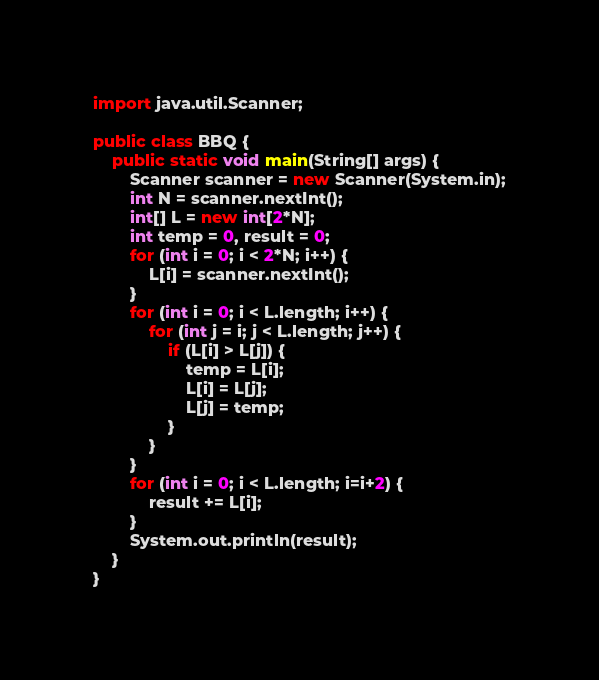<code> <loc_0><loc_0><loc_500><loc_500><_Java_>import java.util.Scanner;

public class BBQ {
    public static void main(String[] args) {
        Scanner scanner = new Scanner(System.in);
        int N = scanner.nextInt();
        int[] L = new int[2*N];
        int temp = 0, result = 0;
        for (int i = 0; i < 2*N; i++) {
            L[i] = scanner.nextInt();
        }
        for (int i = 0; i < L.length; i++) {
            for (int j = i; j < L.length; j++) {
                if (L[i] > L[j]) {
                    temp = L[i];
                    L[i] = L[j];
                    L[j] = temp;
                }
            }
        }
        for (int i = 0; i < L.length; i=i+2) {
            result += L[i];
        }
        System.out.println(result);
    }
}
</code> 